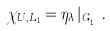Convert formula to latex. <formula><loc_0><loc_0><loc_500><loc_500>\chi _ { U , L _ { 1 } } = \eta _ { \lambda } \, | _ { G _ { L _ { 1 } } } .</formula> 